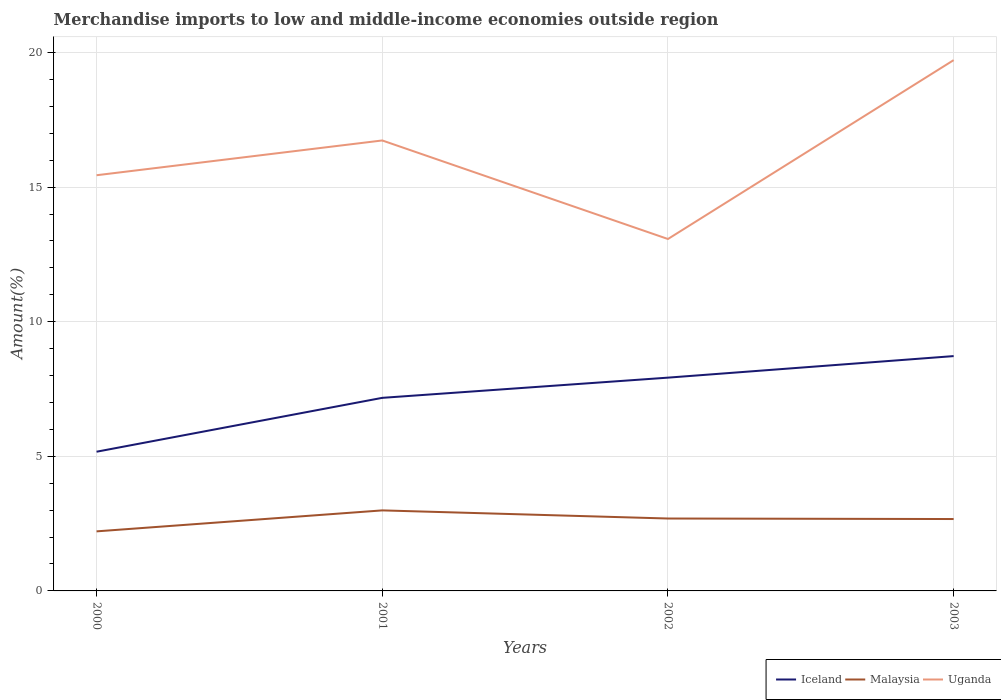How many different coloured lines are there?
Provide a succinct answer. 3. Does the line corresponding to Uganda intersect with the line corresponding to Iceland?
Your response must be concise. No. Is the number of lines equal to the number of legend labels?
Your answer should be compact. Yes. Across all years, what is the maximum percentage of amount earned from merchandise imports in Iceland?
Give a very brief answer. 5.17. What is the total percentage of amount earned from merchandise imports in Uganda in the graph?
Offer a very short reply. 2.37. What is the difference between the highest and the second highest percentage of amount earned from merchandise imports in Iceland?
Your answer should be compact. 3.55. What is the difference between the highest and the lowest percentage of amount earned from merchandise imports in Uganda?
Your answer should be very brief. 2. How many lines are there?
Give a very brief answer. 3. How many years are there in the graph?
Your answer should be very brief. 4. Where does the legend appear in the graph?
Provide a short and direct response. Bottom right. How many legend labels are there?
Your answer should be very brief. 3. What is the title of the graph?
Offer a terse response. Merchandise imports to low and middle-income economies outside region. What is the label or title of the Y-axis?
Your answer should be compact. Amount(%). What is the Amount(%) in Iceland in 2000?
Provide a short and direct response. 5.17. What is the Amount(%) of Malaysia in 2000?
Your response must be concise. 2.21. What is the Amount(%) in Uganda in 2000?
Provide a short and direct response. 15.44. What is the Amount(%) of Iceland in 2001?
Offer a very short reply. 7.17. What is the Amount(%) in Malaysia in 2001?
Give a very brief answer. 2.99. What is the Amount(%) of Uganda in 2001?
Your response must be concise. 16.73. What is the Amount(%) in Iceland in 2002?
Provide a succinct answer. 7.92. What is the Amount(%) of Malaysia in 2002?
Your response must be concise. 2.69. What is the Amount(%) of Uganda in 2002?
Ensure brevity in your answer.  13.07. What is the Amount(%) of Iceland in 2003?
Offer a terse response. 8.72. What is the Amount(%) in Malaysia in 2003?
Provide a short and direct response. 2.67. What is the Amount(%) of Uganda in 2003?
Offer a terse response. 19.72. Across all years, what is the maximum Amount(%) of Iceland?
Keep it short and to the point. 8.72. Across all years, what is the maximum Amount(%) in Malaysia?
Make the answer very short. 2.99. Across all years, what is the maximum Amount(%) in Uganda?
Make the answer very short. 19.72. Across all years, what is the minimum Amount(%) in Iceland?
Make the answer very short. 5.17. Across all years, what is the minimum Amount(%) in Malaysia?
Make the answer very short. 2.21. Across all years, what is the minimum Amount(%) in Uganda?
Give a very brief answer. 13.07. What is the total Amount(%) of Iceland in the graph?
Offer a very short reply. 28.99. What is the total Amount(%) of Malaysia in the graph?
Your response must be concise. 10.56. What is the total Amount(%) in Uganda in the graph?
Offer a terse response. 64.96. What is the difference between the Amount(%) in Iceland in 2000 and that in 2001?
Your answer should be compact. -2. What is the difference between the Amount(%) in Malaysia in 2000 and that in 2001?
Your answer should be compact. -0.78. What is the difference between the Amount(%) of Uganda in 2000 and that in 2001?
Offer a terse response. -1.29. What is the difference between the Amount(%) in Iceland in 2000 and that in 2002?
Give a very brief answer. -2.75. What is the difference between the Amount(%) of Malaysia in 2000 and that in 2002?
Your answer should be very brief. -0.48. What is the difference between the Amount(%) in Uganda in 2000 and that in 2002?
Give a very brief answer. 2.37. What is the difference between the Amount(%) in Iceland in 2000 and that in 2003?
Your response must be concise. -3.55. What is the difference between the Amount(%) of Malaysia in 2000 and that in 2003?
Your response must be concise. -0.46. What is the difference between the Amount(%) in Uganda in 2000 and that in 2003?
Make the answer very short. -4.28. What is the difference between the Amount(%) of Iceland in 2001 and that in 2002?
Provide a succinct answer. -0.75. What is the difference between the Amount(%) of Malaysia in 2001 and that in 2002?
Your answer should be very brief. 0.3. What is the difference between the Amount(%) of Uganda in 2001 and that in 2002?
Ensure brevity in your answer.  3.66. What is the difference between the Amount(%) in Iceland in 2001 and that in 2003?
Offer a very short reply. -1.55. What is the difference between the Amount(%) in Malaysia in 2001 and that in 2003?
Your response must be concise. 0.32. What is the difference between the Amount(%) in Uganda in 2001 and that in 2003?
Ensure brevity in your answer.  -2.98. What is the difference between the Amount(%) of Iceland in 2002 and that in 2003?
Provide a short and direct response. -0.8. What is the difference between the Amount(%) in Malaysia in 2002 and that in 2003?
Offer a terse response. 0.02. What is the difference between the Amount(%) in Uganda in 2002 and that in 2003?
Give a very brief answer. -6.64. What is the difference between the Amount(%) of Iceland in 2000 and the Amount(%) of Malaysia in 2001?
Offer a very short reply. 2.18. What is the difference between the Amount(%) in Iceland in 2000 and the Amount(%) in Uganda in 2001?
Your answer should be very brief. -11.56. What is the difference between the Amount(%) of Malaysia in 2000 and the Amount(%) of Uganda in 2001?
Offer a very short reply. -14.52. What is the difference between the Amount(%) of Iceland in 2000 and the Amount(%) of Malaysia in 2002?
Make the answer very short. 2.48. What is the difference between the Amount(%) in Iceland in 2000 and the Amount(%) in Uganda in 2002?
Offer a terse response. -7.9. What is the difference between the Amount(%) in Malaysia in 2000 and the Amount(%) in Uganda in 2002?
Offer a terse response. -10.86. What is the difference between the Amount(%) of Iceland in 2000 and the Amount(%) of Malaysia in 2003?
Your answer should be compact. 2.5. What is the difference between the Amount(%) of Iceland in 2000 and the Amount(%) of Uganda in 2003?
Provide a short and direct response. -14.54. What is the difference between the Amount(%) of Malaysia in 2000 and the Amount(%) of Uganda in 2003?
Provide a succinct answer. -17.5. What is the difference between the Amount(%) of Iceland in 2001 and the Amount(%) of Malaysia in 2002?
Make the answer very short. 4.48. What is the difference between the Amount(%) in Iceland in 2001 and the Amount(%) in Uganda in 2002?
Make the answer very short. -5.9. What is the difference between the Amount(%) of Malaysia in 2001 and the Amount(%) of Uganda in 2002?
Your answer should be compact. -10.08. What is the difference between the Amount(%) of Iceland in 2001 and the Amount(%) of Malaysia in 2003?
Your answer should be very brief. 4.5. What is the difference between the Amount(%) of Iceland in 2001 and the Amount(%) of Uganda in 2003?
Offer a very short reply. -12.54. What is the difference between the Amount(%) of Malaysia in 2001 and the Amount(%) of Uganda in 2003?
Provide a succinct answer. -16.72. What is the difference between the Amount(%) in Iceland in 2002 and the Amount(%) in Malaysia in 2003?
Your answer should be compact. 5.25. What is the difference between the Amount(%) of Iceland in 2002 and the Amount(%) of Uganda in 2003?
Your answer should be very brief. -11.79. What is the difference between the Amount(%) in Malaysia in 2002 and the Amount(%) in Uganda in 2003?
Your response must be concise. -17.03. What is the average Amount(%) in Iceland per year?
Ensure brevity in your answer.  7.25. What is the average Amount(%) of Malaysia per year?
Keep it short and to the point. 2.64. What is the average Amount(%) of Uganda per year?
Your answer should be compact. 16.24. In the year 2000, what is the difference between the Amount(%) in Iceland and Amount(%) in Malaysia?
Your answer should be very brief. 2.96. In the year 2000, what is the difference between the Amount(%) of Iceland and Amount(%) of Uganda?
Offer a very short reply. -10.27. In the year 2000, what is the difference between the Amount(%) of Malaysia and Amount(%) of Uganda?
Ensure brevity in your answer.  -13.23. In the year 2001, what is the difference between the Amount(%) in Iceland and Amount(%) in Malaysia?
Your answer should be compact. 4.18. In the year 2001, what is the difference between the Amount(%) of Iceland and Amount(%) of Uganda?
Your response must be concise. -9.56. In the year 2001, what is the difference between the Amount(%) of Malaysia and Amount(%) of Uganda?
Your answer should be compact. -13.74. In the year 2002, what is the difference between the Amount(%) in Iceland and Amount(%) in Malaysia?
Provide a short and direct response. 5.23. In the year 2002, what is the difference between the Amount(%) of Iceland and Amount(%) of Uganda?
Give a very brief answer. -5.15. In the year 2002, what is the difference between the Amount(%) of Malaysia and Amount(%) of Uganda?
Make the answer very short. -10.38. In the year 2003, what is the difference between the Amount(%) in Iceland and Amount(%) in Malaysia?
Your answer should be very brief. 6.05. In the year 2003, what is the difference between the Amount(%) in Iceland and Amount(%) in Uganda?
Your response must be concise. -10.99. In the year 2003, what is the difference between the Amount(%) of Malaysia and Amount(%) of Uganda?
Your answer should be compact. -17.05. What is the ratio of the Amount(%) of Iceland in 2000 to that in 2001?
Your answer should be compact. 0.72. What is the ratio of the Amount(%) in Malaysia in 2000 to that in 2001?
Keep it short and to the point. 0.74. What is the ratio of the Amount(%) in Uganda in 2000 to that in 2001?
Offer a terse response. 0.92. What is the ratio of the Amount(%) in Iceland in 2000 to that in 2002?
Your response must be concise. 0.65. What is the ratio of the Amount(%) in Malaysia in 2000 to that in 2002?
Offer a terse response. 0.82. What is the ratio of the Amount(%) in Uganda in 2000 to that in 2002?
Provide a succinct answer. 1.18. What is the ratio of the Amount(%) in Iceland in 2000 to that in 2003?
Provide a short and direct response. 0.59. What is the ratio of the Amount(%) in Malaysia in 2000 to that in 2003?
Ensure brevity in your answer.  0.83. What is the ratio of the Amount(%) in Uganda in 2000 to that in 2003?
Provide a short and direct response. 0.78. What is the ratio of the Amount(%) of Iceland in 2001 to that in 2002?
Offer a very short reply. 0.91. What is the ratio of the Amount(%) of Malaysia in 2001 to that in 2002?
Keep it short and to the point. 1.11. What is the ratio of the Amount(%) in Uganda in 2001 to that in 2002?
Make the answer very short. 1.28. What is the ratio of the Amount(%) in Iceland in 2001 to that in 2003?
Provide a succinct answer. 0.82. What is the ratio of the Amount(%) of Malaysia in 2001 to that in 2003?
Provide a short and direct response. 1.12. What is the ratio of the Amount(%) in Uganda in 2001 to that in 2003?
Give a very brief answer. 0.85. What is the ratio of the Amount(%) of Iceland in 2002 to that in 2003?
Offer a terse response. 0.91. What is the ratio of the Amount(%) of Malaysia in 2002 to that in 2003?
Give a very brief answer. 1.01. What is the ratio of the Amount(%) in Uganda in 2002 to that in 2003?
Give a very brief answer. 0.66. What is the difference between the highest and the second highest Amount(%) in Iceland?
Your response must be concise. 0.8. What is the difference between the highest and the second highest Amount(%) in Malaysia?
Your answer should be compact. 0.3. What is the difference between the highest and the second highest Amount(%) in Uganda?
Ensure brevity in your answer.  2.98. What is the difference between the highest and the lowest Amount(%) of Iceland?
Keep it short and to the point. 3.55. What is the difference between the highest and the lowest Amount(%) of Malaysia?
Ensure brevity in your answer.  0.78. What is the difference between the highest and the lowest Amount(%) in Uganda?
Your answer should be very brief. 6.64. 